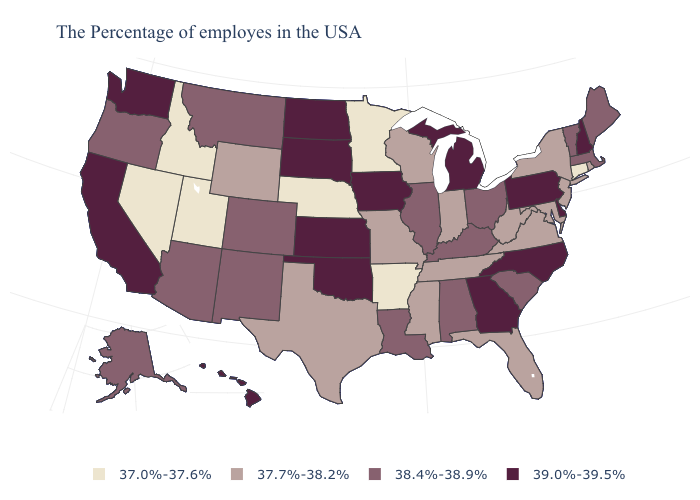Name the states that have a value in the range 37.7%-38.2%?
Write a very short answer. Rhode Island, New York, New Jersey, Maryland, Virginia, West Virginia, Florida, Indiana, Tennessee, Wisconsin, Mississippi, Missouri, Texas, Wyoming. What is the value of Louisiana?
Keep it brief. 38.4%-38.9%. What is the lowest value in the Northeast?
Keep it brief. 37.0%-37.6%. Name the states that have a value in the range 37.7%-38.2%?
Short answer required. Rhode Island, New York, New Jersey, Maryland, Virginia, West Virginia, Florida, Indiana, Tennessee, Wisconsin, Mississippi, Missouri, Texas, Wyoming. Does Maine have a lower value than North Dakota?
Concise answer only. Yes. Does Arkansas have the lowest value in the South?
Write a very short answer. Yes. What is the value of Delaware?
Concise answer only. 39.0%-39.5%. How many symbols are there in the legend?
Short answer required. 4. What is the value of Wisconsin?
Answer briefly. 37.7%-38.2%. Does the map have missing data?
Be succinct. No. What is the value of Kentucky?
Give a very brief answer. 38.4%-38.9%. What is the value of South Carolina?
Write a very short answer. 38.4%-38.9%. Name the states that have a value in the range 38.4%-38.9%?
Write a very short answer. Maine, Massachusetts, Vermont, South Carolina, Ohio, Kentucky, Alabama, Illinois, Louisiana, Colorado, New Mexico, Montana, Arizona, Oregon, Alaska. What is the highest value in the MidWest ?
Concise answer only. 39.0%-39.5%. What is the value of Louisiana?
Give a very brief answer. 38.4%-38.9%. 